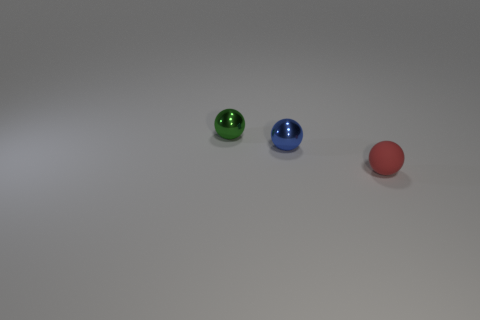There is a green metal thing that is the same size as the blue thing; what is its shape?
Ensure brevity in your answer.  Sphere. Are there any metallic things behind the tiny green metallic sphere?
Your answer should be compact. No. Does the small sphere that is on the right side of the small blue metal ball have the same material as the small sphere on the left side of the blue metallic ball?
Provide a short and direct response. No. How many other metallic objects have the same size as the green object?
Your answer should be very brief. 1. What material is the object that is to the right of the tiny blue object?
Your response must be concise. Rubber. How many other shiny things have the same shape as the green thing?
Offer a terse response. 1. There is a small blue thing that is made of the same material as the green object; what is its shape?
Your response must be concise. Sphere. What is the shape of the object right of the small shiny thing to the right of the small metallic thing that is behind the tiny blue metal sphere?
Ensure brevity in your answer.  Sphere. Is the number of yellow cubes greater than the number of blue balls?
Keep it short and to the point. No. There is a blue object that is the same shape as the small green thing; what material is it?
Give a very brief answer. Metal. 